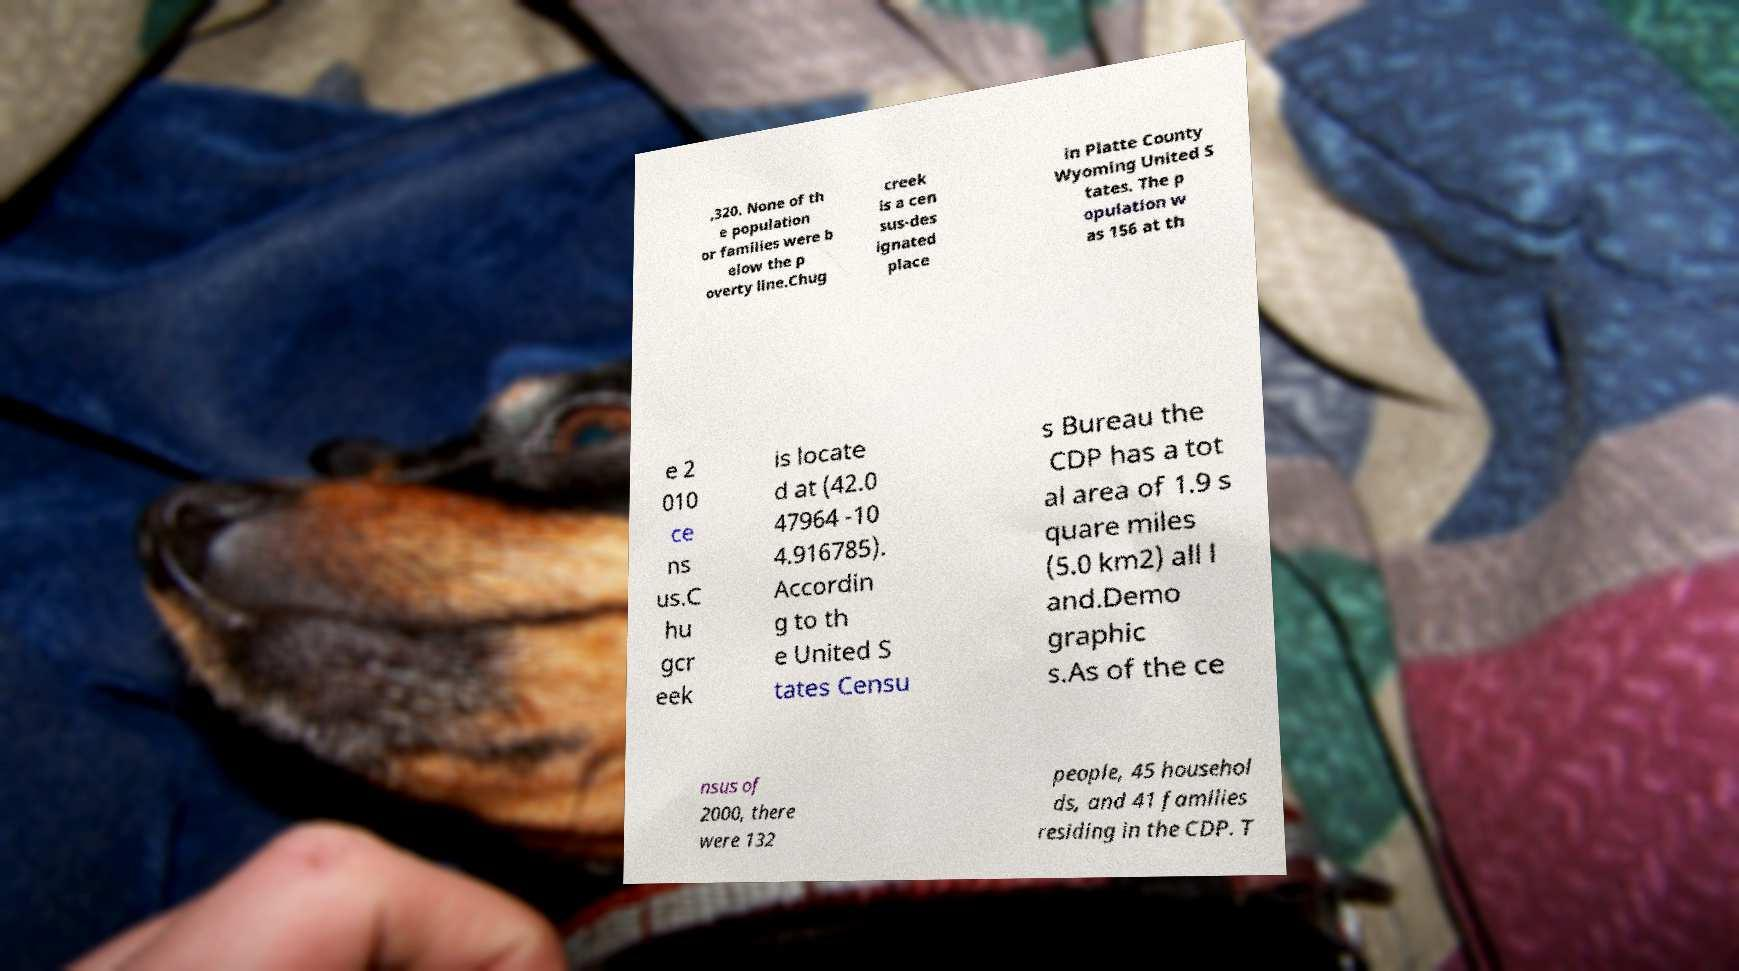Please identify and transcribe the text found in this image. ,320. None of th e population or families were b elow the p overty line.Chug creek is a cen sus-des ignated place in Platte County Wyoming United S tates. The p opulation w as 156 at th e 2 010 ce ns us.C hu gcr eek is locate d at (42.0 47964 -10 4.916785). Accordin g to th e United S tates Censu s Bureau the CDP has a tot al area of 1.9 s quare miles (5.0 km2) all l and.Demo graphic s.As of the ce nsus of 2000, there were 132 people, 45 househol ds, and 41 families residing in the CDP. T 